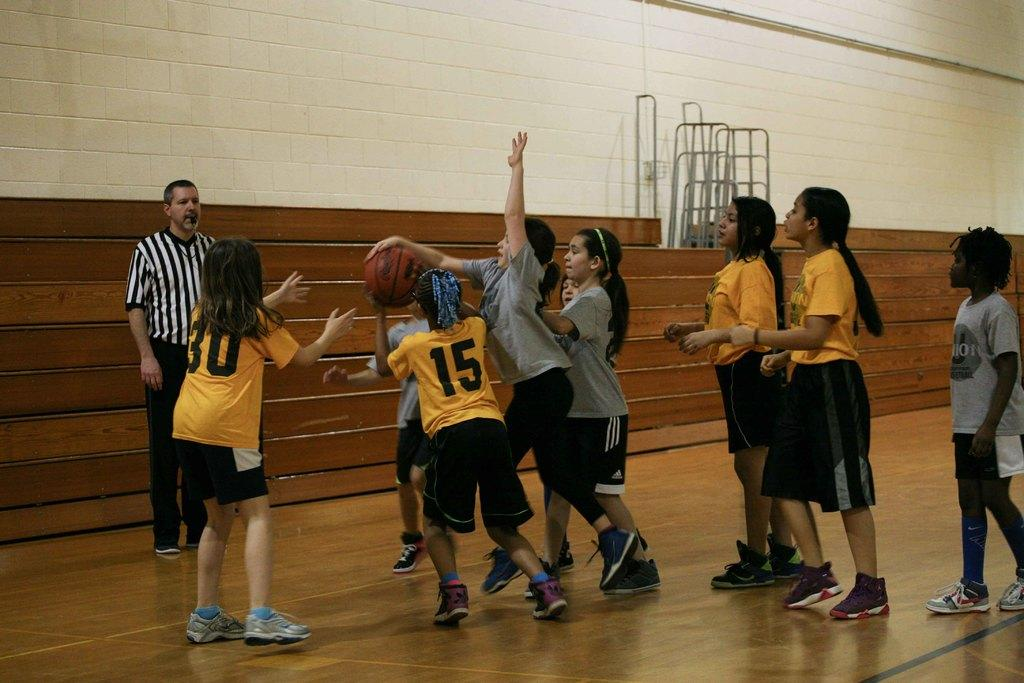What is the girl in the image trying to do? The girl in the image is trying to hit a ball. Are there any other people in the image besides the girl? Yes, there are other girls standing nearby and a man in the image. What is the purpose of the wall in the image? The purpose of the wall in the image is not specified, but it could be a boundary or a backdrop for the activity. What rule does the airplane enforce in the image? There is no airplane present in the image, so no rule can be enforced by an airplane. 